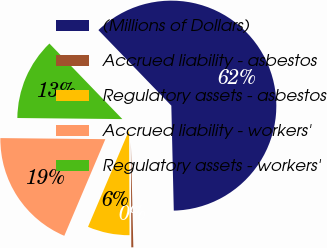Convert chart to OTSL. <chart><loc_0><loc_0><loc_500><loc_500><pie_chart><fcel>(Millions of Dollars)<fcel>Accrued liability - asbestos<fcel>Regulatory assets - asbestos<fcel>Accrued liability - workers'<fcel>Regulatory assets - workers'<nl><fcel>61.85%<fcel>0.31%<fcel>6.46%<fcel>18.77%<fcel>12.62%<nl></chart> 